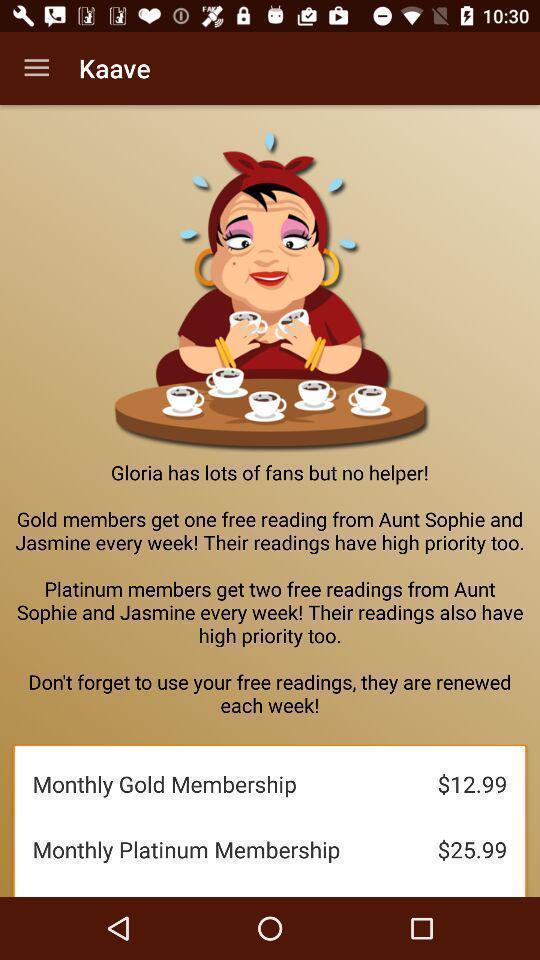Describe the visual elements of this screenshot. Screen shows membership options. 